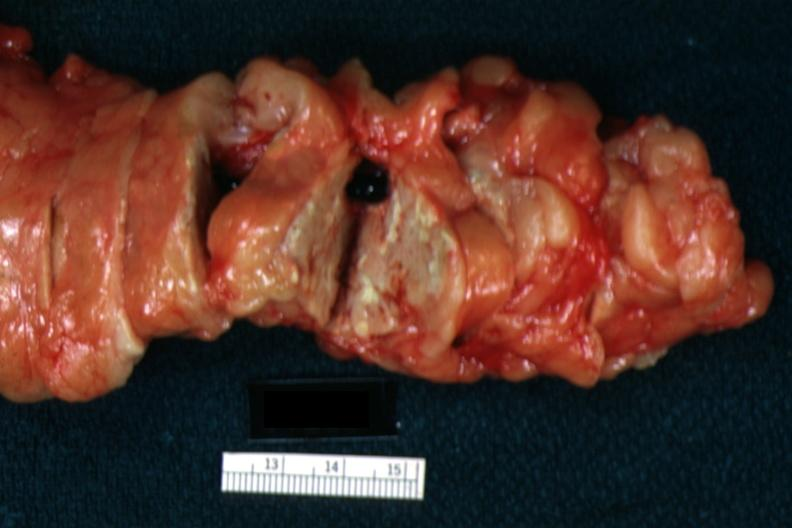does bone nearly completely filled with tumor primary show fat necrosis well seen with no evident parenchymal lesion?
Answer the question using a single word or phrase. No 